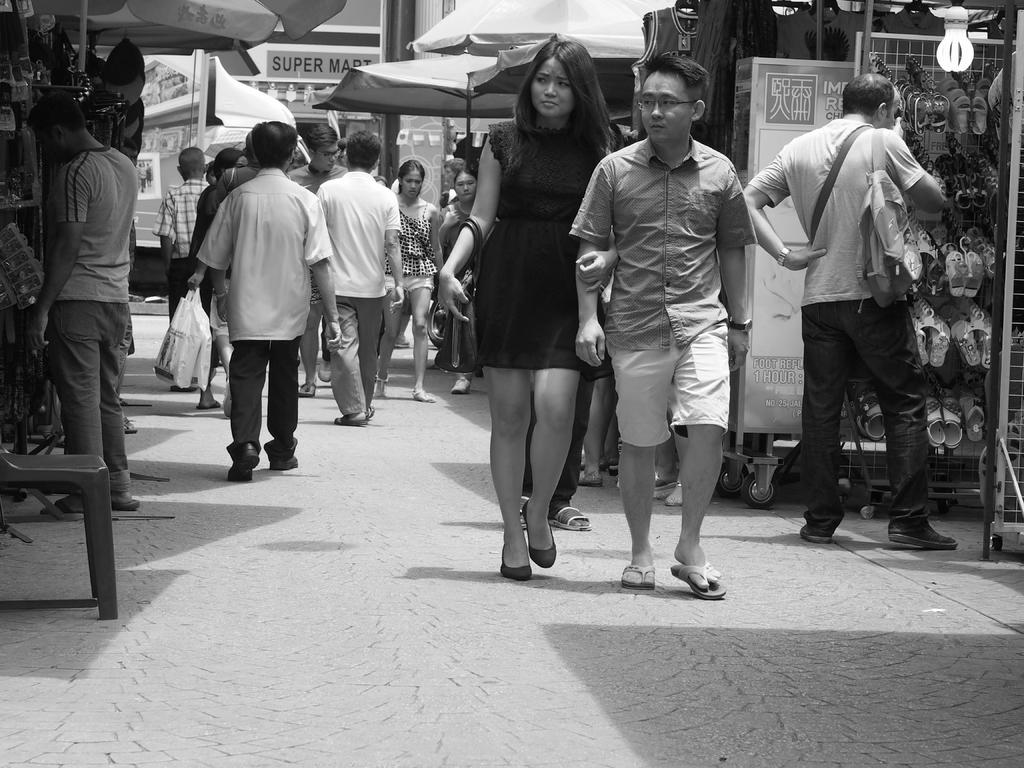What are the people in the image doing? There are people standing and walking in the image. What can be seen on the ground in the image? The ground is visible in the image. What is the source of light in the image? There is a bulb in the image. What is present for sitting in the image? There is a stool in the image. What type of clothing accessory is present in the image? Footwear is present in the image. What can be used for protection from rain in the image? Umbrellas are visible in the image. What is visible in the background of the image? There are objects in the background of the image. What type of frame is visible in the image? There is no frame present in the image. What type of meeting is taking place in the image? There is no meeting depicted in the image. 